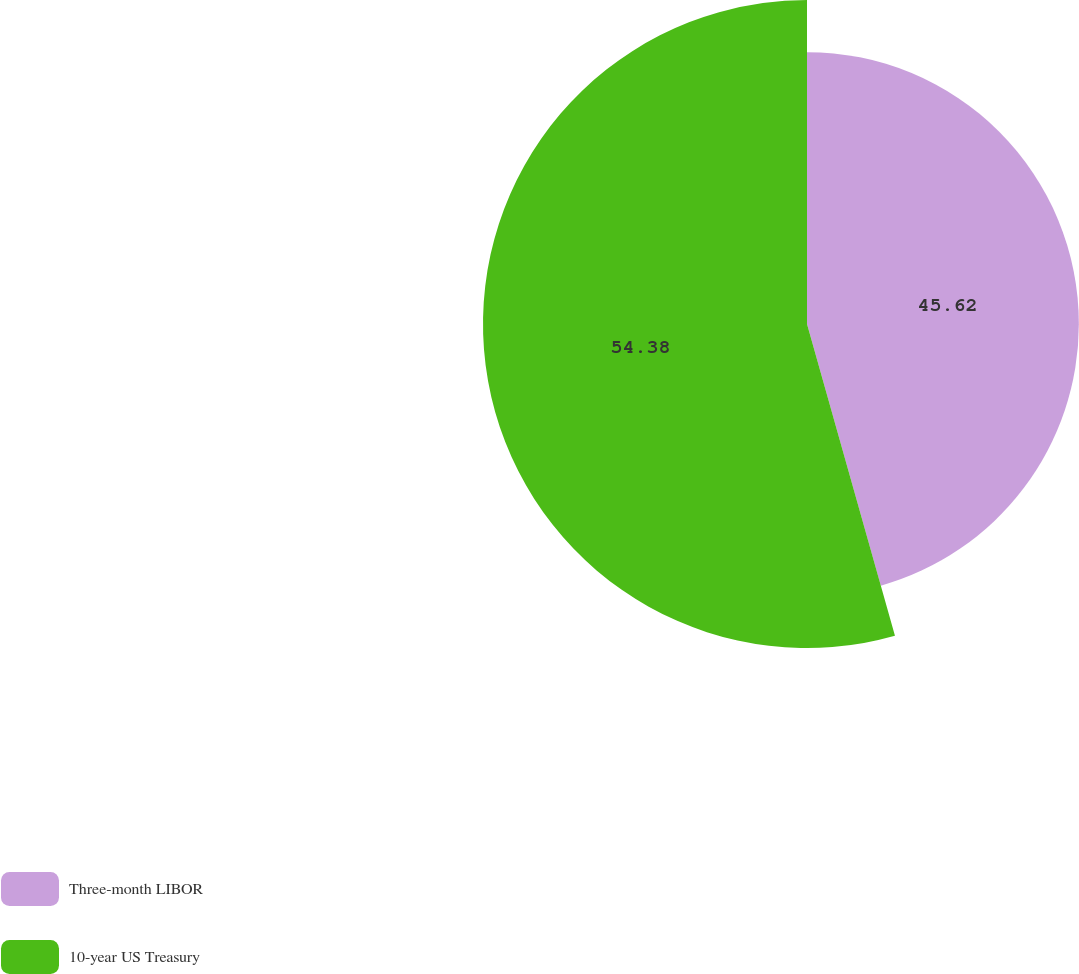<chart> <loc_0><loc_0><loc_500><loc_500><pie_chart><fcel>Three-month LIBOR<fcel>10-year US Treasury<nl><fcel>45.62%<fcel>54.37%<nl></chart> 